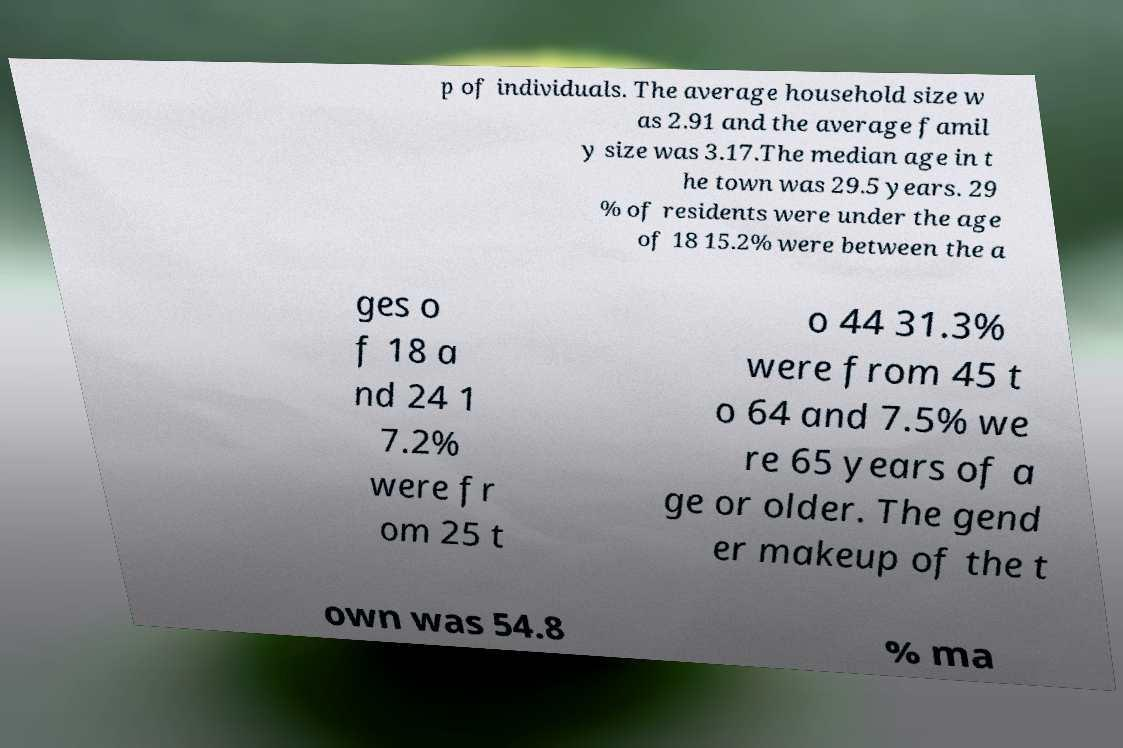Can you read and provide the text displayed in the image?This photo seems to have some interesting text. Can you extract and type it out for me? p of individuals. The average household size w as 2.91 and the average famil y size was 3.17.The median age in t he town was 29.5 years. 29 % of residents were under the age of 18 15.2% were between the a ges o f 18 a nd 24 1 7.2% were fr om 25 t o 44 31.3% were from 45 t o 64 and 7.5% we re 65 years of a ge or older. The gend er makeup of the t own was 54.8 % ma 